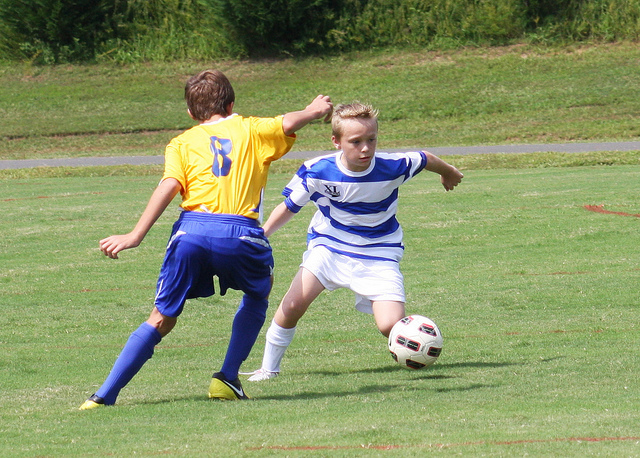Read and extract the text from this image. 8 XL 